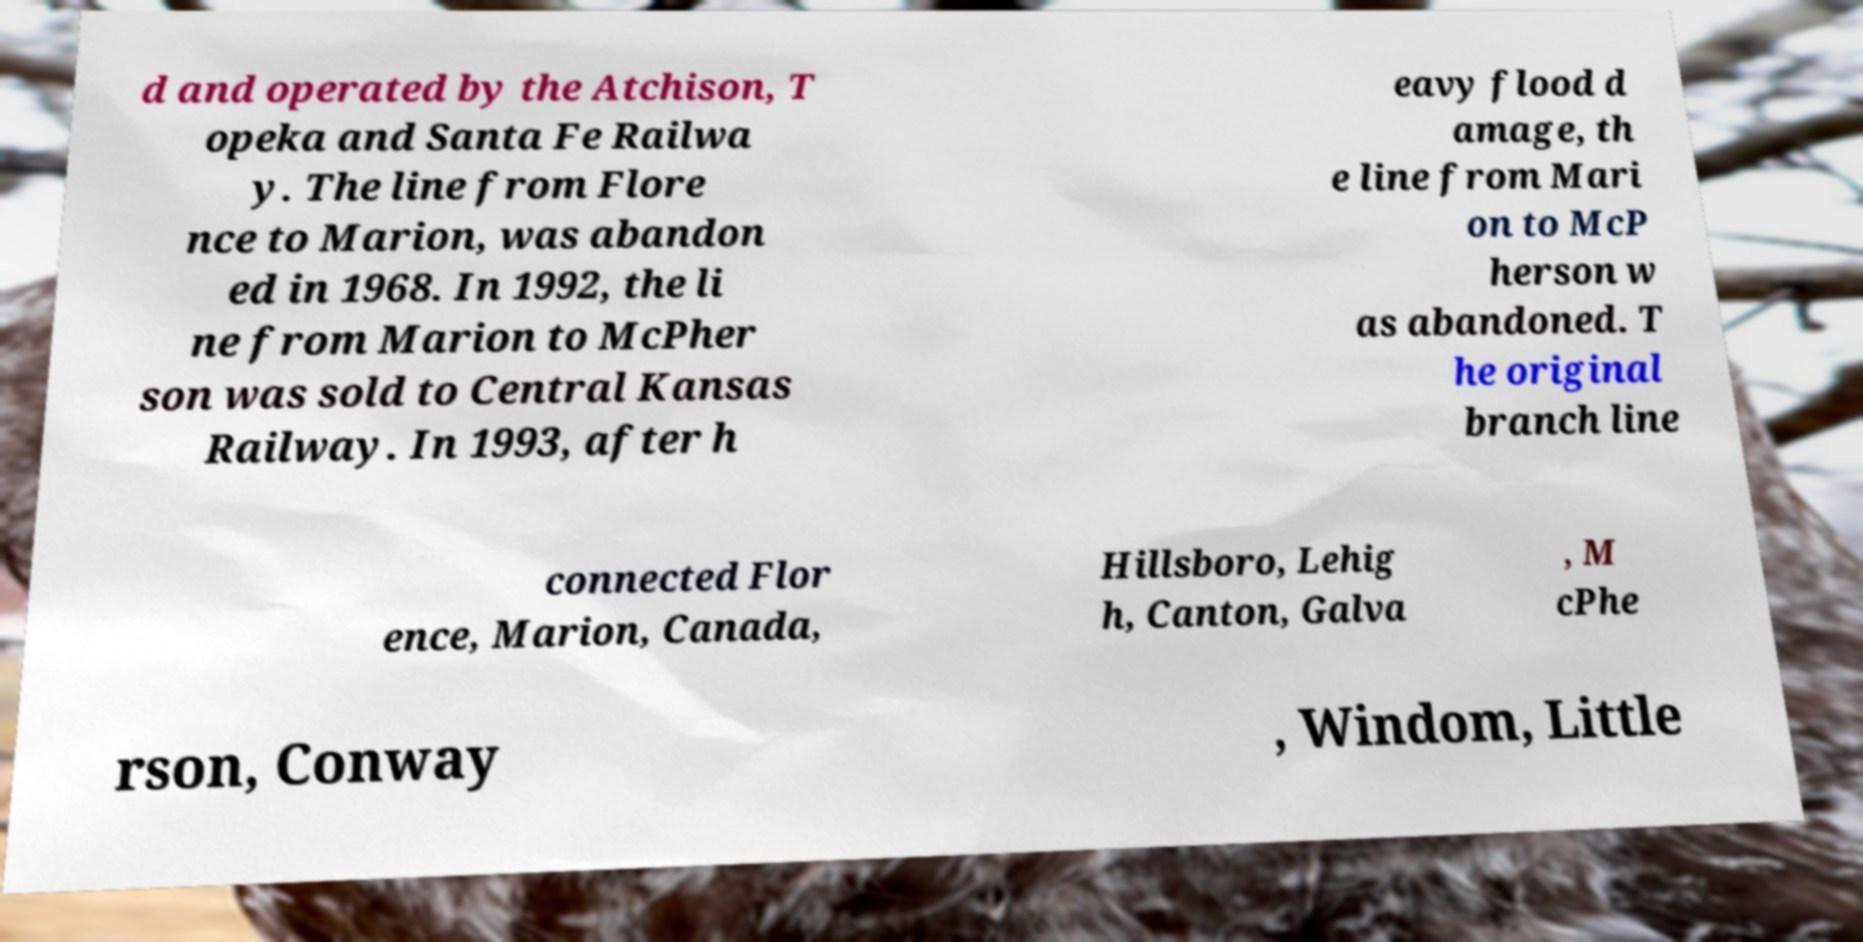Could you assist in decoding the text presented in this image and type it out clearly? d and operated by the Atchison, T opeka and Santa Fe Railwa y. The line from Flore nce to Marion, was abandon ed in 1968. In 1992, the li ne from Marion to McPher son was sold to Central Kansas Railway. In 1993, after h eavy flood d amage, th e line from Mari on to McP herson w as abandoned. T he original branch line connected Flor ence, Marion, Canada, Hillsboro, Lehig h, Canton, Galva , M cPhe rson, Conway , Windom, Little 